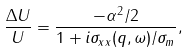Convert formula to latex. <formula><loc_0><loc_0><loc_500><loc_500>\frac { \Delta U } { U } = \frac { - \alpha ^ { 2 } / 2 } { 1 + i \sigma _ { x x } ( q , \omega ) / \sigma _ { m } } ,</formula> 